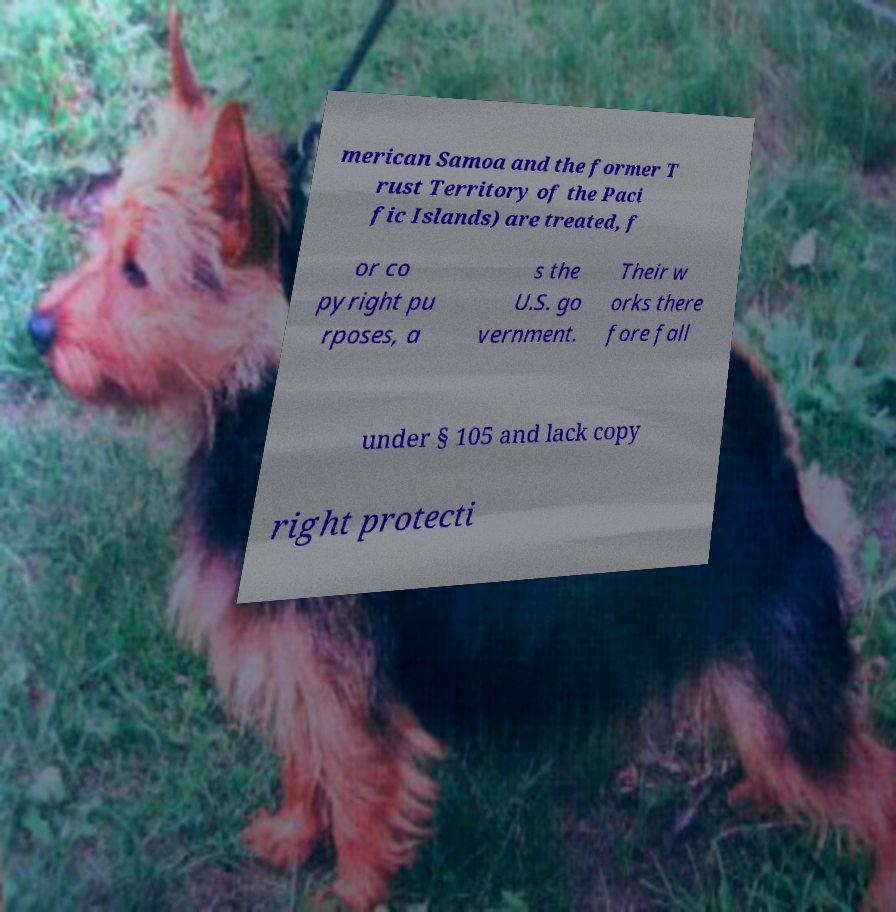Please read and relay the text visible in this image. What does it say? merican Samoa and the former T rust Territory of the Paci fic Islands) are treated, f or co pyright pu rposes, a s the U.S. go vernment. Their w orks there fore fall under § 105 and lack copy right protecti 